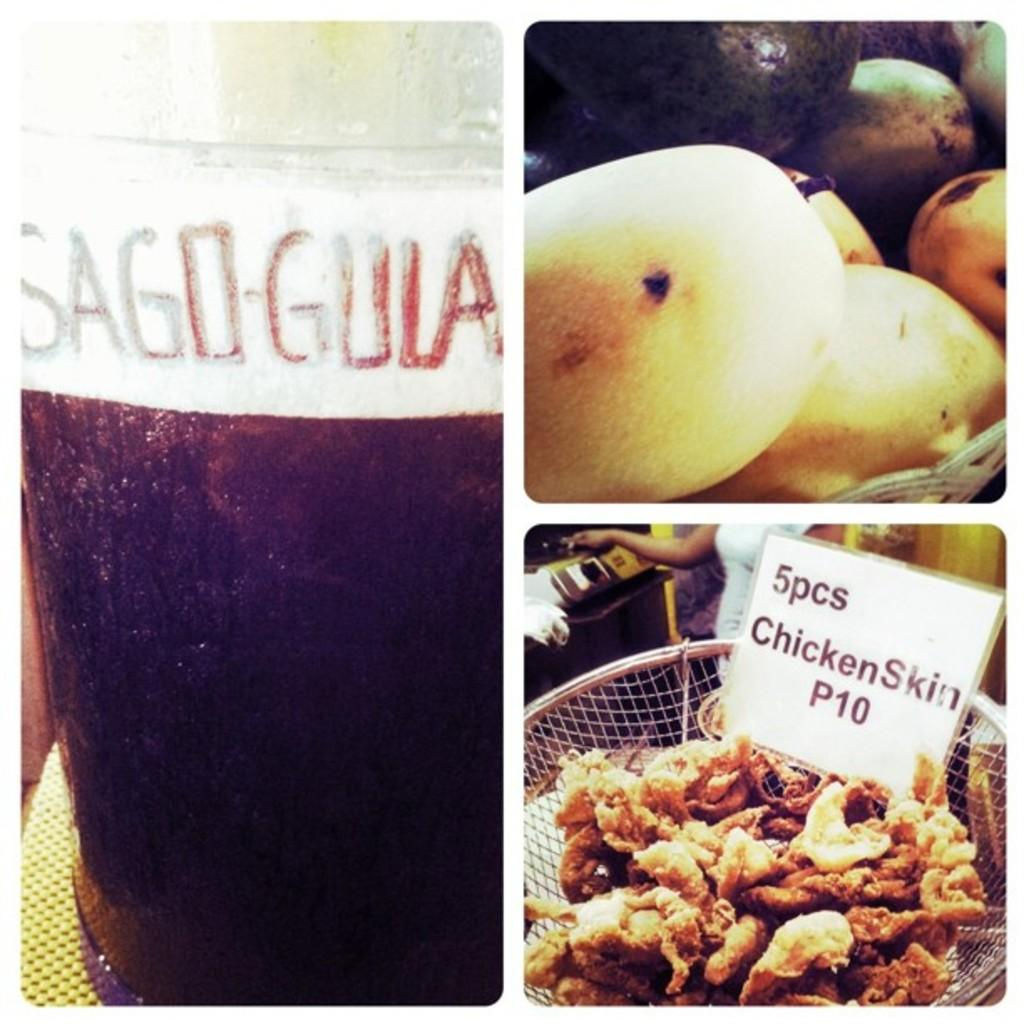How many images are combined in the collage? The image is a collage of three images. What can be seen in the bottom image? There are people, a chart, and food items in the bottom image. What type of food items are present in the bottom image? There are vegetables in the bottom image. What is in the jar in the left image? There is a drink in a jar in the left image. What type of cheese is present in the middle image? There is no middle image, and no cheese is present in the collage. 